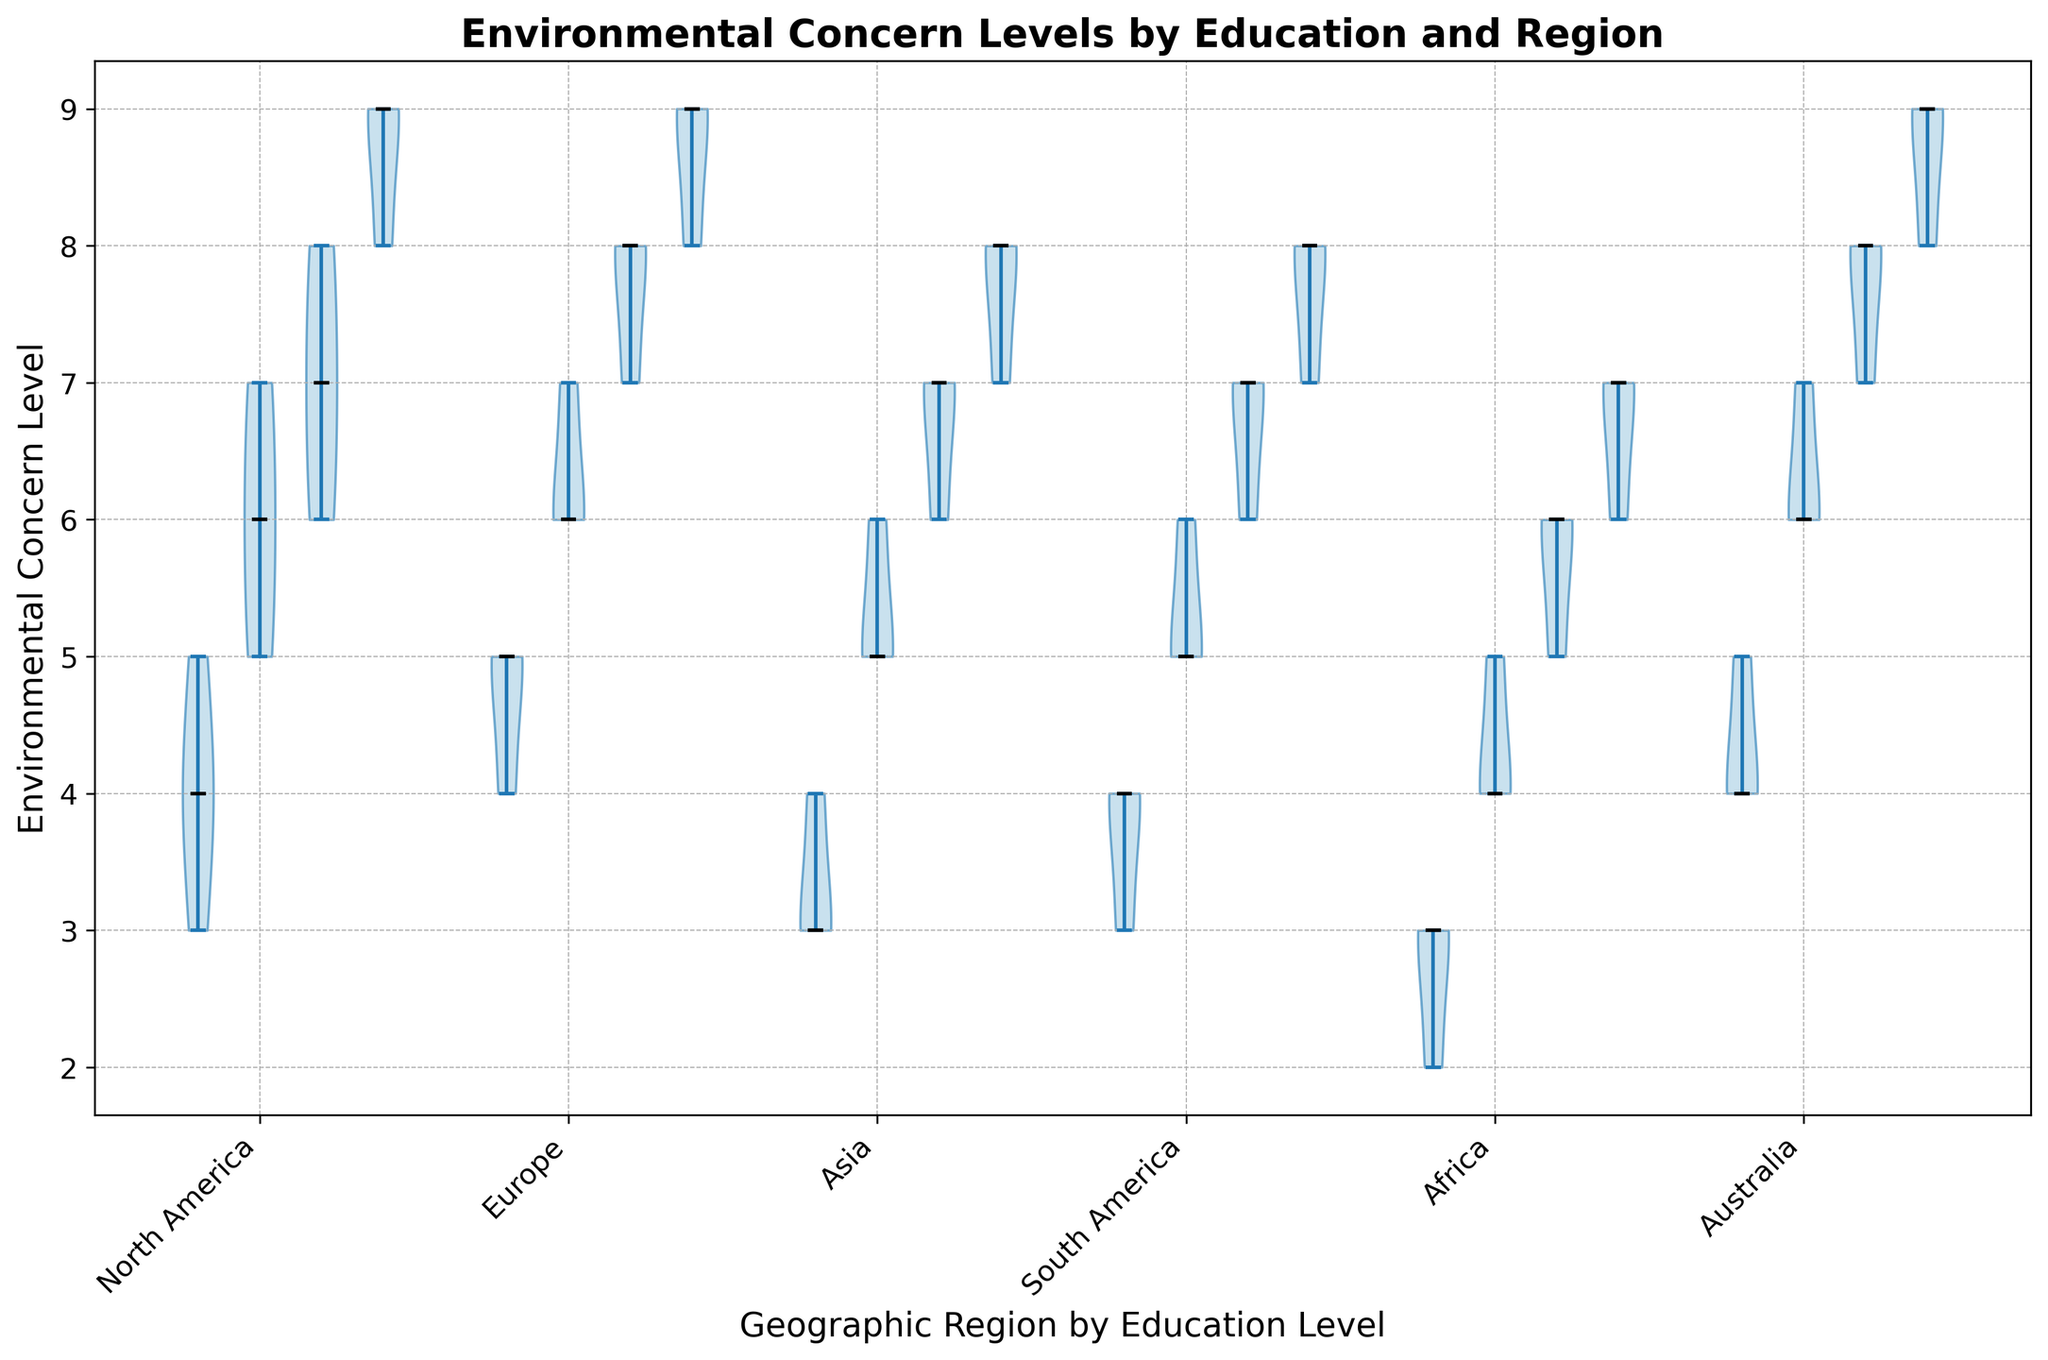What is the median environmental concern level among people with a PhD in North America? Find the median value by identifying the middle value in the sorted environmental concern levels of PhD holders in North America, which are [8, 9, 9]. The median is 9.
Answer: 9 Which geographic region shows the highest median environmental concern level for Bachelor’s degree holders? Compare the median environmental concern levels for Bachelor's degree holders across all regions. North America has 6, Europe has 6, Asia has 5, South America has 5.5, Africa has 4, and Australia has 6. So, Europe, North America, and Australia all show the highest median with a level of 6.
Answer: North America, Europe, and Australia Are environmental concern levels generally higher among PhD holders compared to High School graduates across all regions? For each region, compare the median environmental concern levels of people with PhDs to those with High School education. For instance, in North America, PhD is 9 and High School is 4; similarly for other regions. In all cases, PhD holders have higher median levels compared to High School graduates.
Answer: Yes What is the average of the median environmental concern levels for Master’s degree holders in Europe and Asia? Calculate the median for Master’s degree holders: Europe = 8, Asia = 7. Then, average them: (8 + 7) / 2 = 7.5.
Answer: 7.5 Which education level shows the most consistent environmental concern levels in South America? The most consistent group will have the smallest spread in the violin plot. For South America, look for the narrowest section of the violins: High School ranges [3, 4], Bachelor's ranges [5, 6], Master's ranges [6, 7], and PhD ranges [7, 8]. High School and Bachelor's appear equally consistent.
Answer: High School and Bachelor's Compared to Europe, how does the median environmental concern level for Master’s degree holders in North America differ? North America's median for Master's degree holders is 7, while Europe's is 8. Thus, North America's median is 1 unit lower.
Answer: 1 unit lower Does Australia have a generally higher or lower concern level compared to Africa for High School education? Determine the median concern levels for High School education: Australia = 4.5, Africa = 3. Australia's is higher.
Answer: Higher What is the visual trend of environmental concern levels as the education level increases in Asia? Observe the violin plots in Asia: High School has medians around 3.5, Bachelor's around 5.33, Master's around 6.67, and PhD around 7.67. This shows an increasing trend in concern levels with higher education levels.
Answer: Increasing Does the range of environmental concern levels for Bachelor’s degree holders differ significantly between North America and Australia? Visually compare the spread of the Bachelor’s degree holders' violin plots in both North America and Australia. North America ranges [5, 7] and Australia ranges [6, 7], indicating a slightly smaller range in Australia.
Answer: No, not significantly Which education level has the highest median environmental concern level in Europe? Identify and compare medians: High School = 5, Bachelor's = 6, Master's = 8, PhD = 9. PhD has the highest median.
Answer: PhD 